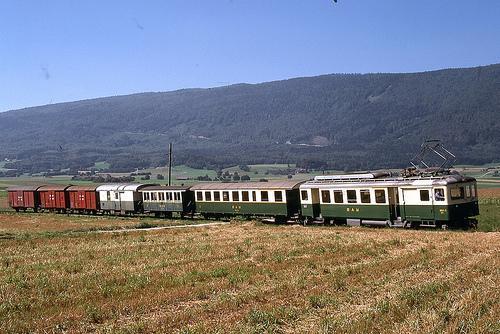How many cars are on the train?
Give a very brief answer. 7. How many green and white train cars are there?
Give a very brief answer. 2. 